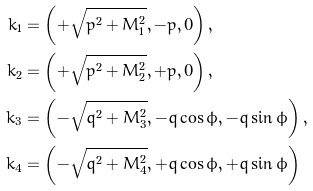Convert formula to latex. <formula><loc_0><loc_0><loc_500><loc_500>k _ { 1 } & = \left ( + \sqrt { p ^ { 2 } + M _ { 1 } ^ { 2 } } , - p , 0 \right ) , \\ k _ { 2 } & = \left ( + \sqrt { p ^ { 2 } + M _ { 2 } ^ { 2 } } , + p , 0 \right ) , \\ k _ { 3 } & = \left ( - \sqrt { q ^ { 2 } + M _ { 3 } ^ { 2 } } , - q \cos \phi , - q \sin \phi \right ) , \\ k _ { 4 } & = \left ( - \sqrt { q ^ { 2 } + M _ { 4 } ^ { 2 } } , + q \cos \phi , + q \sin \phi \right )</formula> 